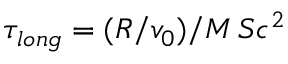<formula> <loc_0><loc_0><loc_500><loc_500>\tau _ { l o n g } = ( R / v _ { 0 } ) / M \, S c ^ { 2 }</formula> 